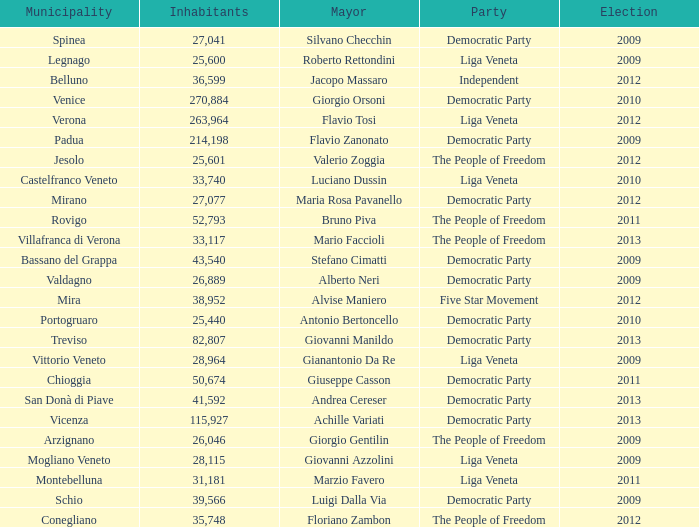What party was achille variati afilliated with? Democratic Party. 